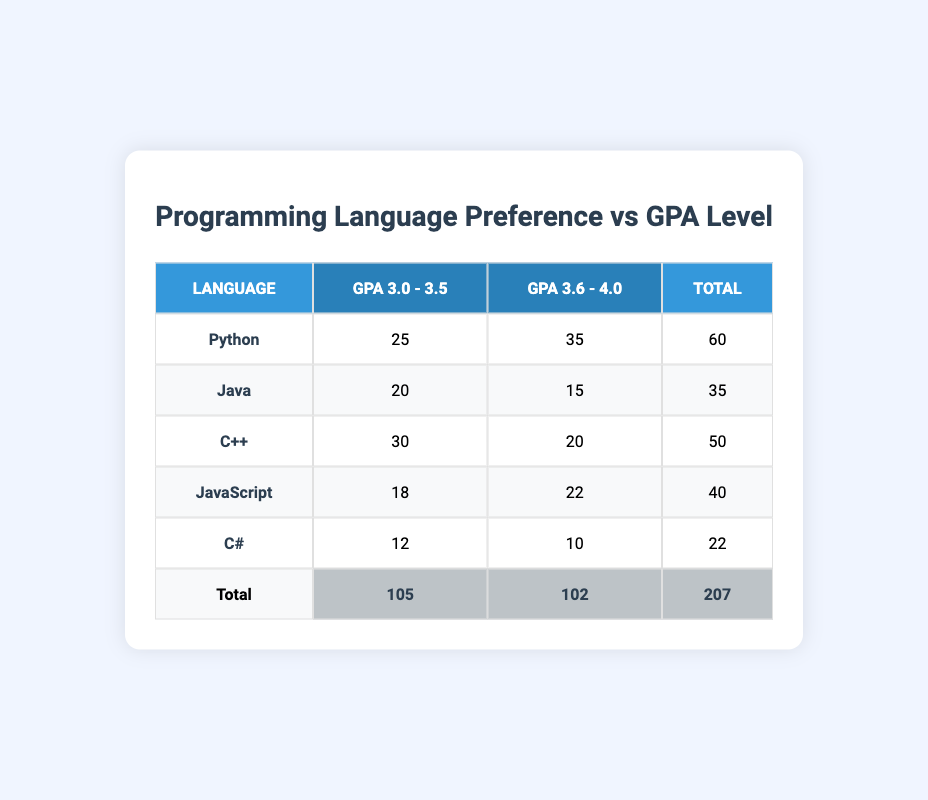What is the total number of respondents who preferred Python? In the table, for Python, the total count is listed as 60, which is obtained by adding the counts from the two GPA levels: 25 (for 3.0 - 3.5) + 35 (for 3.6 - 4.0) = 60.
Answer: 60 Which programming language has the highest preference among students with a GPA of 3.0 - 3.5? Looking at the 3.0 - 3.5 GPA column, Python has the highest count of 25, compared to Java (20), C++ (30), JavaScript (18), and C# (12).
Answer: C++ What is the difference in total respondents between Java and C++? The total for Java is 35 and for C++ is 50. The difference is calculated by subtracting Java's total from C++'s total: 50 - 35 = 15.
Answer: 15 Is there a programming language that has the same number of respondents for both GPA levels? By examining each language's counts across both GPA levels, no language has the same count in both levels; all counts differ across the GPA ranges.
Answer: No What is the average number of respondents for all programming languages across both GPA levels? The total number of respondents is 207. There are 5 programming languages, so the average is calculated by dividing the total by the number of languages: 207 / 5 = 41.4.
Answer: 41.4 How many more respondents preferred C++ compared to JavaScript? The total for C++ is 50 and for JavaScript is 40. The difference is 50 - 40 = 10.
Answer: 10 Which GPA level had the highest total number of respondents? The total number of respondents for GPA 3.0 - 3.5 is 105, while for GPA 3.6 - 4.0 it is 102, so 3.0 - 3.5 has the highest total.
Answer: 3.0 - 3.5 If you combine the counts for Python and C#, how many respondents preferred these languages? The total for Python is 60 and for C# is 22. The combined count is 60 + 22 = 82.
Answer: 82 What percentage of total respondents preferred Java? The total for Java is 35 out of a grand total of 207. The percentage can be calculated as (35 / 207) * 100, which equals approximately 16.9%.
Answer: 16.9% 